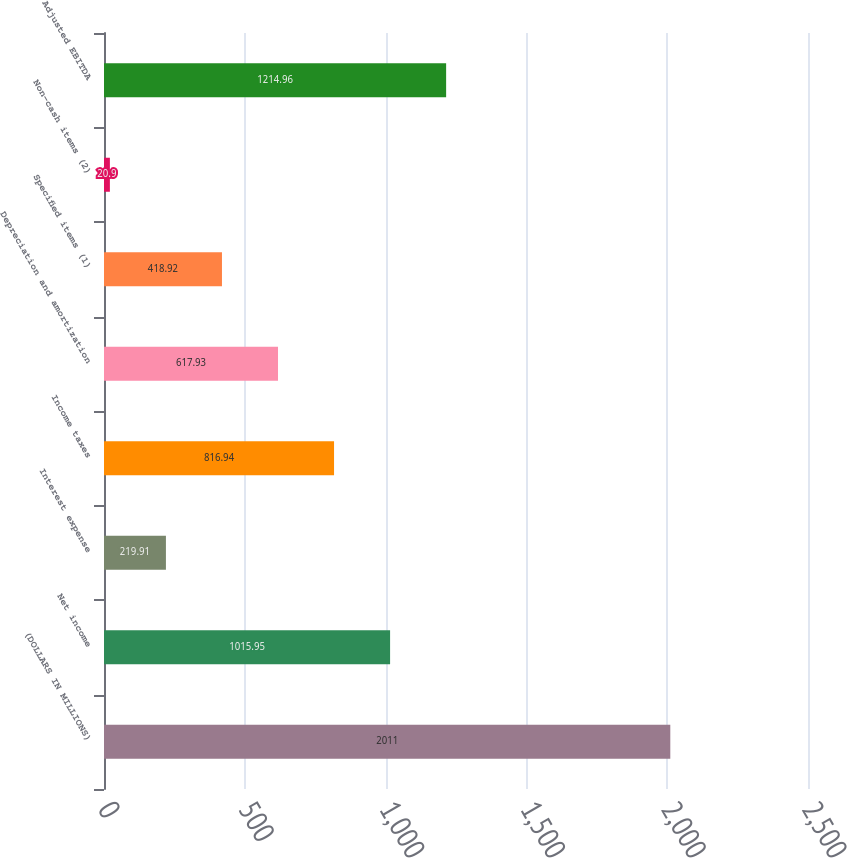Convert chart to OTSL. <chart><loc_0><loc_0><loc_500><loc_500><bar_chart><fcel>(DOLLARS IN MILLIONS)<fcel>Net income<fcel>Interest expense<fcel>Income taxes<fcel>Depreciation and amortization<fcel>Specified items (1)<fcel>Non-cash items (2)<fcel>Adjusted EBITDA<nl><fcel>2011<fcel>1015.95<fcel>219.91<fcel>816.94<fcel>617.93<fcel>418.92<fcel>20.9<fcel>1214.96<nl></chart> 